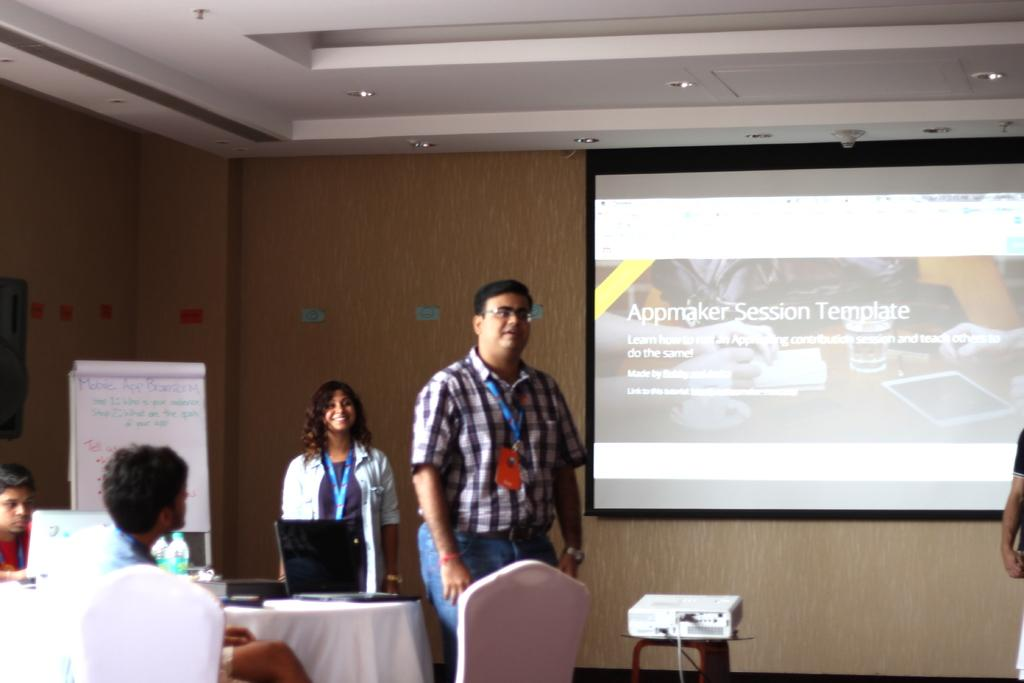What type of structure can be seen in the image? There is a wall in the image. What device is present for displaying information? There is a screen in the image. What are the people in the image doing? The people in the image are standing and sitting. What device is used to project images onto the screen? There is a projector in the image. What surface is available for writing or displaying information? There is a white color board in the image. What type of quartz is used to create the screen in the image? There is no mention of quartz in the image, and the screen is not described as being made of quartz. 